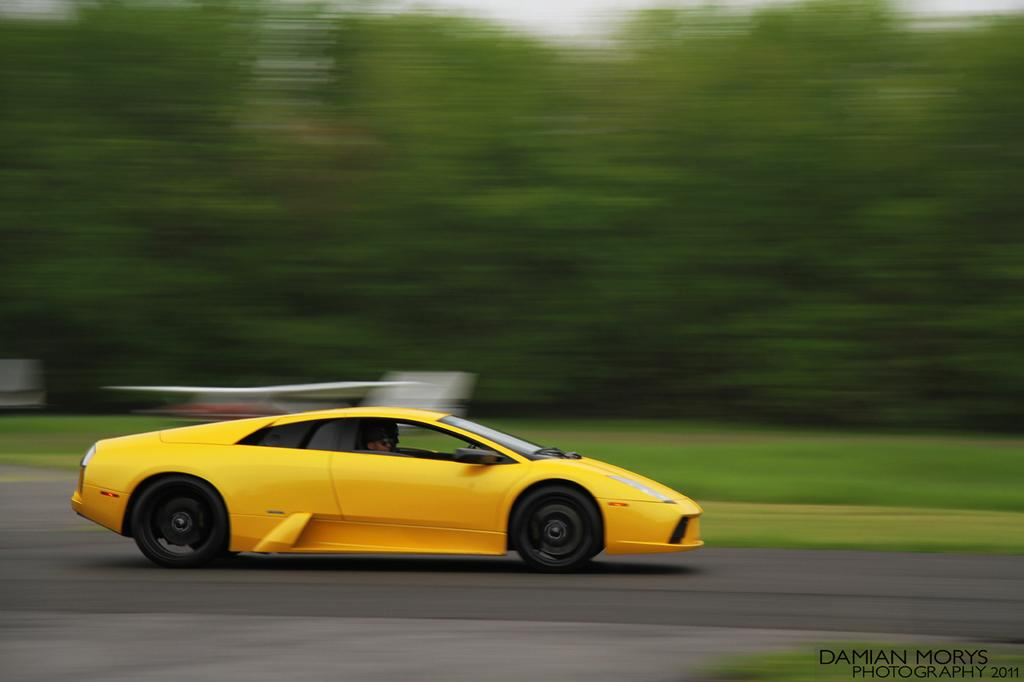What is the main subject of the image? The main subject of the image is a person driving a car. Are there any other people in the car? Yes, there is another person in the car. Where is the car located? The car is on the road. What can be seen in the background of the image? There is green grass and trees visible in the background of the image. What type of bell can be heard ringing in the image? There is no bell present or ringing in the image. Is there a maid visible in the image? There is no maid present in the image. 